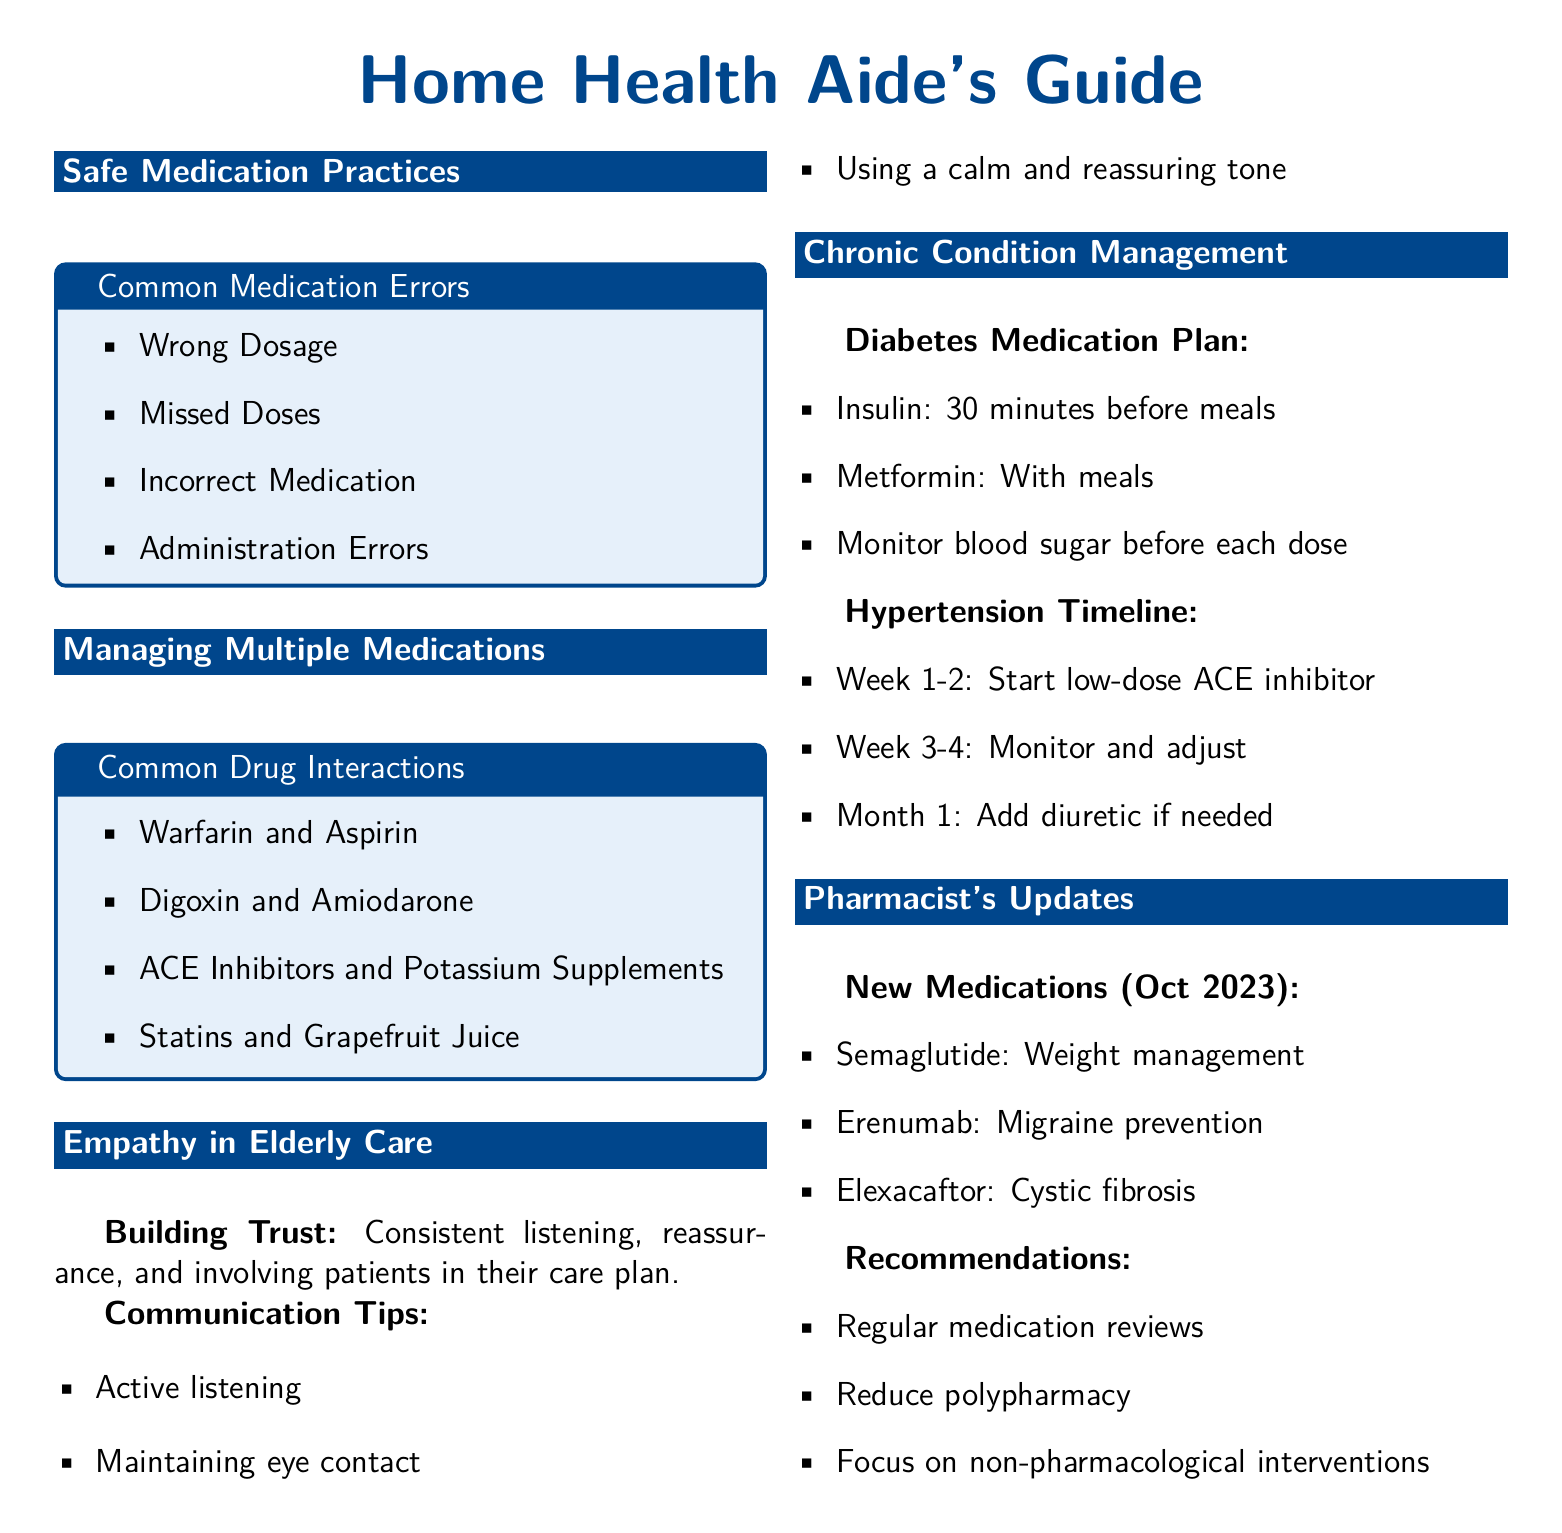What are common medication errors? The document lists common medication errors such as wrong dosage, missed doses, incorrect medication, and administration errors.
Answer: wrong dosage, missed doses, incorrect medication, administration errors What is a common drug interaction with Warfarin? The document states that Warfarin commonly interacts with Aspirin.
Answer: Aspirin What is a key communication tip for home health aides? The document highlights active listening as a key communication tip for building trust and effective communication.
Answer: Active listening What should be monitored before each dose of insulin? The document specifies that blood sugar levels should be monitored before each dose of insulin.
Answer: blood sugar What new medication is mentioned for weight management? The document includes Semaglutide as a new medication for weight management released in October 2023.
Answer: Semaglutide What is emphasized in the pharmacist's recommendations? The document emphasizes the importance of regular medication reviews in the pharmacist's recommendations.
Answer: Regular medication reviews How long should a low-dose ACE inhibitor be started for hypertension management? The document states to start the low-dose ACE inhibitor for two weeks for hypertension management.
Answer: 2 weeks What type of guide is provided for chronic condition management? The document provides a medication plan as a type of guide for managing chronic conditions like diabetes.
Answer: medication plan What skills are highlighted for building trust in elderly care? The document highlights consistent listening, reassurance, and involving patients in their care plan as skills for building trust.
Answer: consistent listening, reassurance, involving patients in care plan 